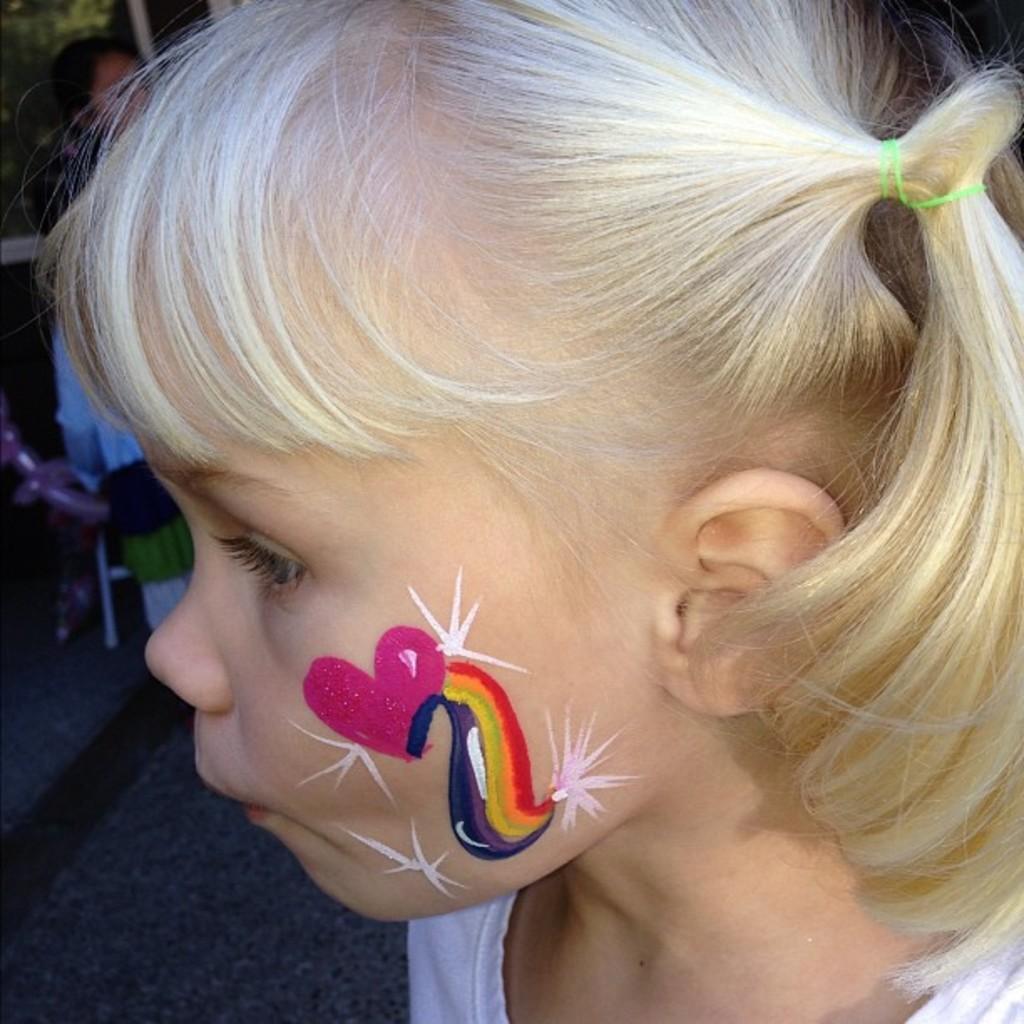Could you give a brief overview of what you see in this image? In this picture we can see a girl's face with a pink heart, stars and colors painted on her cheeks. In the background, we can see trees and people on the road. 